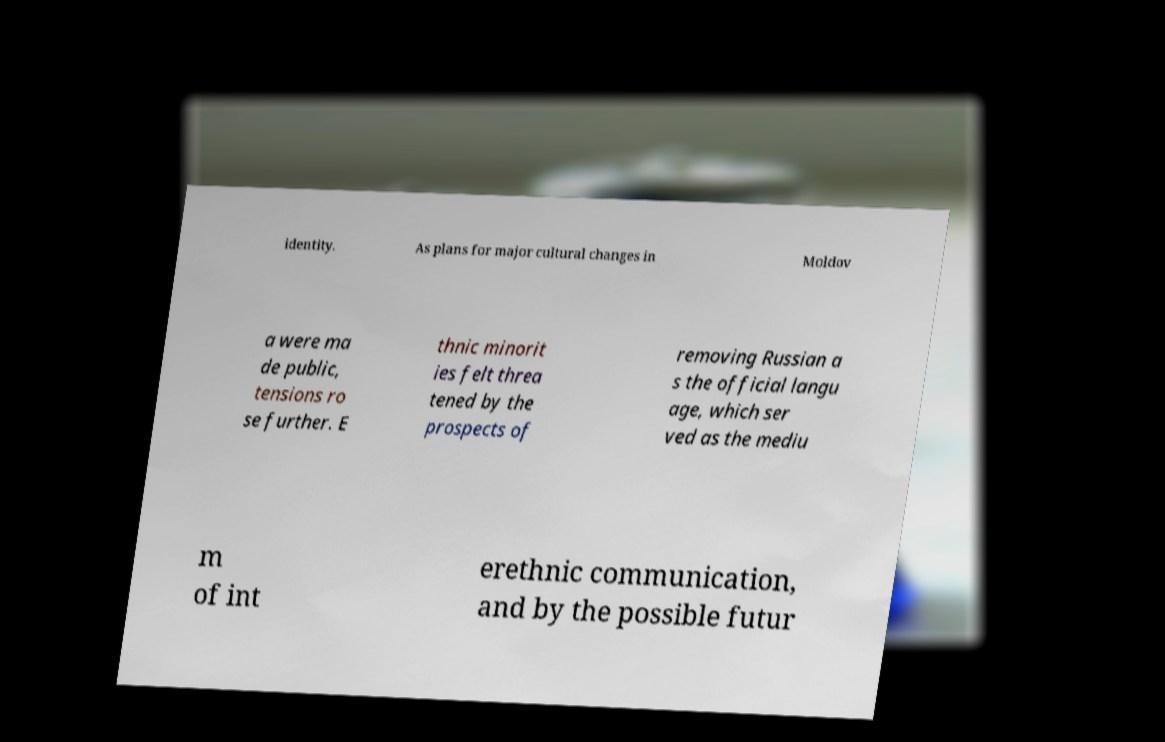There's text embedded in this image that I need extracted. Can you transcribe it verbatim? identity. As plans for major cultural changes in Moldov a were ma de public, tensions ro se further. E thnic minorit ies felt threa tened by the prospects of removing Russian a s the official langu age, which ser ved as the mediu m of int erethnic communication, and by the possible futur 